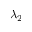<formula> <loc_0><loc_0><loc_500><loc_500>\lambda _ { 2 }</formula> 